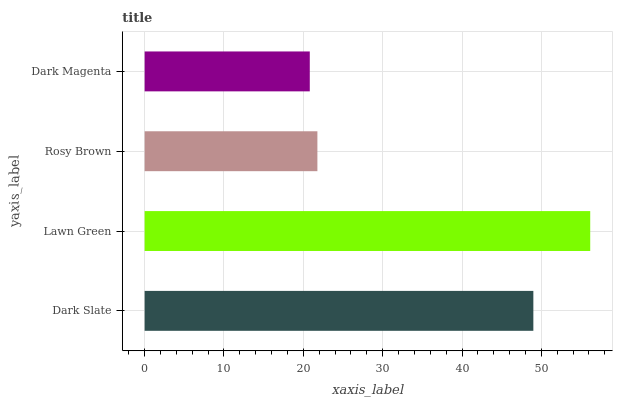Is Dark Magenta the minimum?
Answer yes or no. Yes. Is Lawn Green the maximum?
Answer yes or no. Yes. Is Rosy Brown the minimum?
Answer yes or no. No. Is Rosy Brown the maximum?
Answer yes or no. No. Is Lawn Green greater than Rosy Brown?
Answer yes or no. Yes. Is Rosy Brown less than Lawn Green?
Answer yes or no. Yes. Is Rosy Brown greater than Lawn Green?
Answer yes or no. No. Is Lawn Green less than Rosy Brown?
Answer yes or no. No. Is Dark Slate the high median?
Answer yes or no. Yes. Is Rosy Brown the low median?
Answer yes or no. Yes. Is Lawn Green the high median?
Answer yes or no. No. Is Lawn Green the low median?
Answer yes or no. No. 